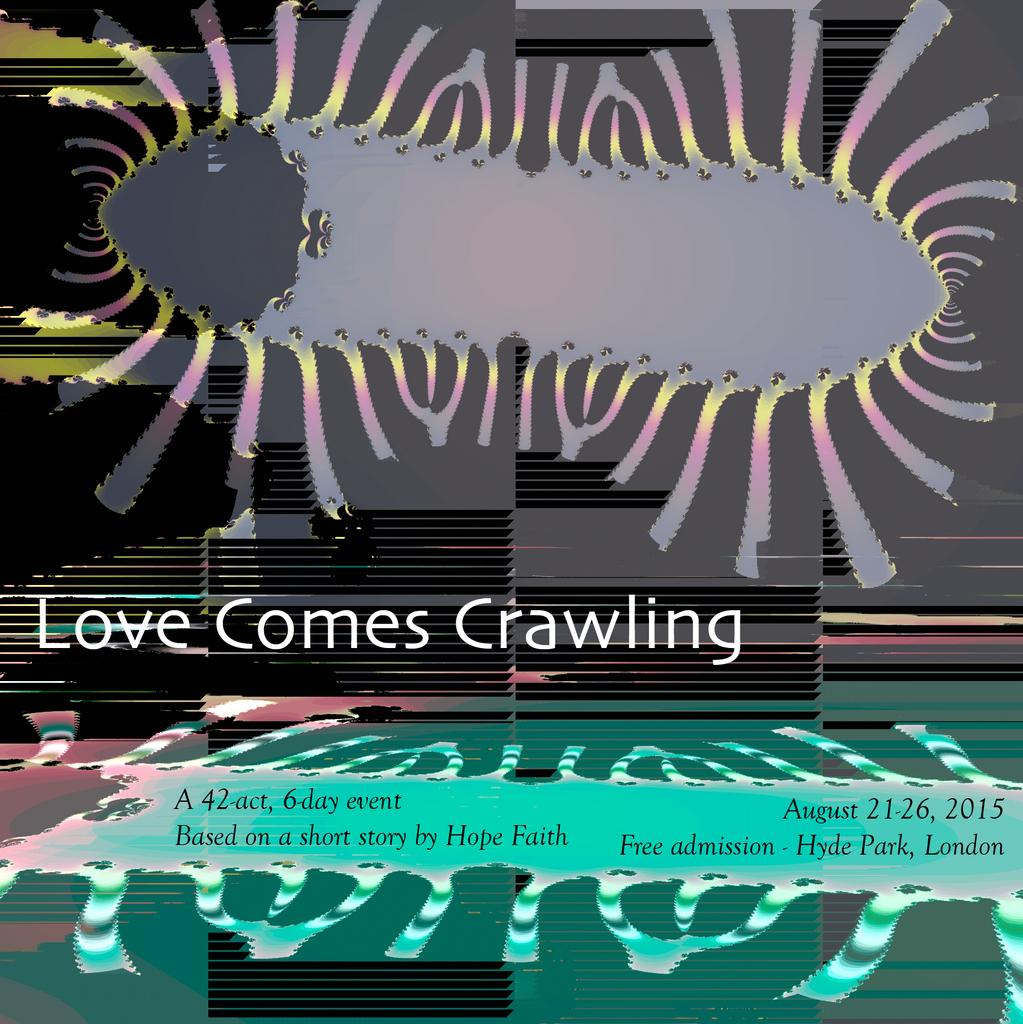<image>
Offer a succinct explanation of the picture presented. A poster that says Love Comes Crawling on it. 